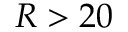Convert formula to latex. <formula><loc_0><loc_0><loc_500><loc_500>R > 2 0</formula> 